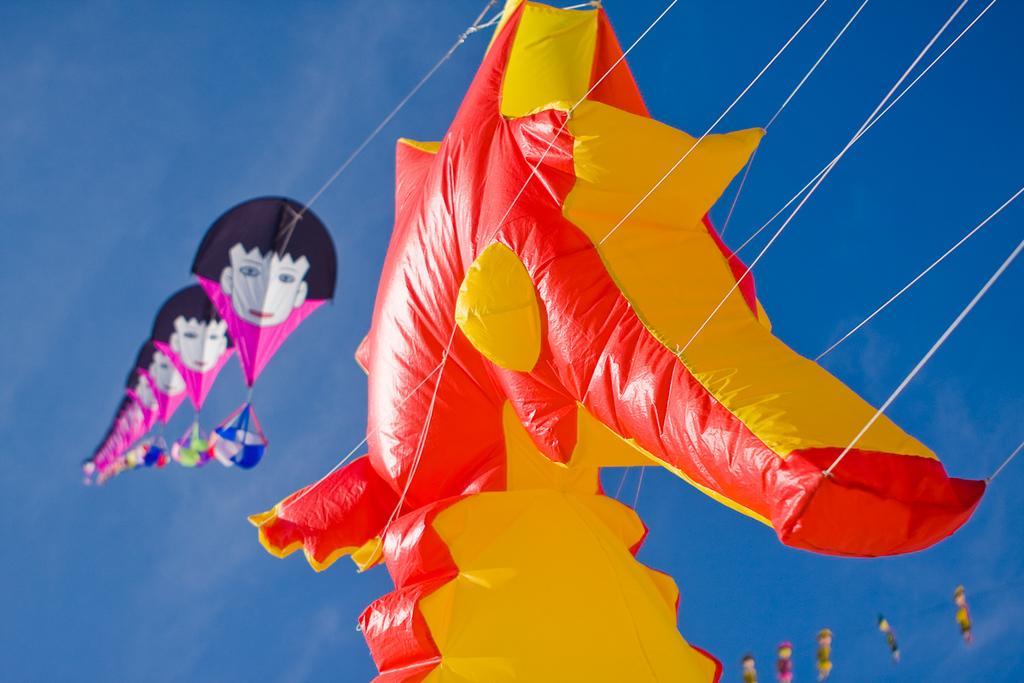In one or two sentences, can you explain what this image depicts? In the image we can see flying kites in the middle of the air with strings attached to it. 